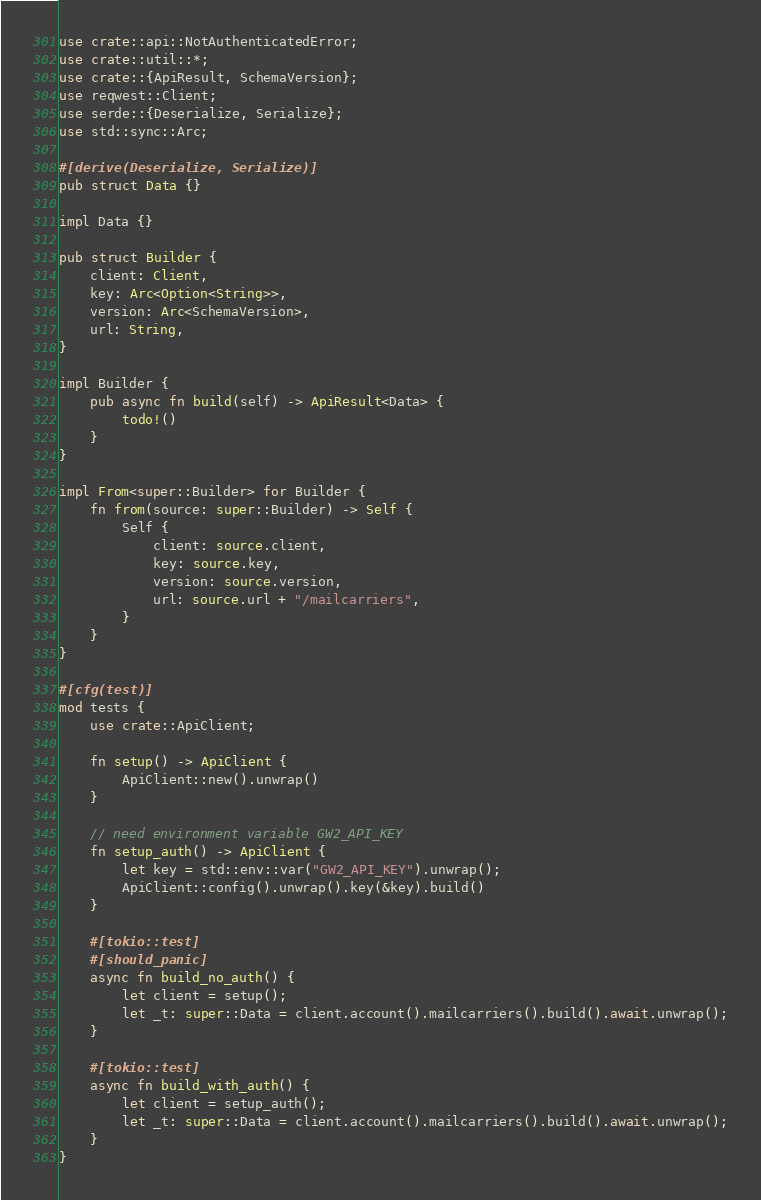Convert code to text. <code><loc_0><loc_0><loc_500><loc_500><_Rust_>use crate::api::NotAuthenticatedError;
use crate::util::*;
use crate::{ApiResult, SchemaVersion};
use reqwest::Client;
use serde::{Deserialize, Serialize};
use std::sync::Arc;

#[derive(Deserialize, Serialize)]
pub struct Data {}

impl Data {}

pub struct Builder {
    client: Client,
    key: Arc<Option<String>>,
    version: Arc<SchemaVersion>,
    url: String,
}

impl Builder {
    pub async fn build(self) -> ApiResult<Data> {
        todo!()
    }
}

impl From<super::Builder> for Builder {
    fn from(source: super::Builder) -> Self {
        Self {
            client: source.client,
            key: source.key,
            version: source.version,
            url: source.url + "/mailcarriers",
        }
    }
}

#[cfg(test)]
mod tests {
    use crate::ApiClient;

    fn setup() -> ApiClient {
        ApiClient::new().unwrap()
    }

    // need environment variable GW2_API_KEY
    fn setup_auth() -> ApiClient {
        let key = std::env::var("GW2_API_KEY").unwrap();
        ApiClient::config().unwrap().key(&key).build()
    }

    #[tokio::test]
    #[should_panic]
    async fn build_no_auth() {
        let client = setup();
        let _t: super::Data = client.account().mailcarriers().build().await.unwrap();
    }

    #[tokio::test]
    async fn build_with_auth() {
        let client = setup_auth();
        let _t: super::Data = client.account().mailcarriers().build().await.unwrap();
    }
}
</code> 